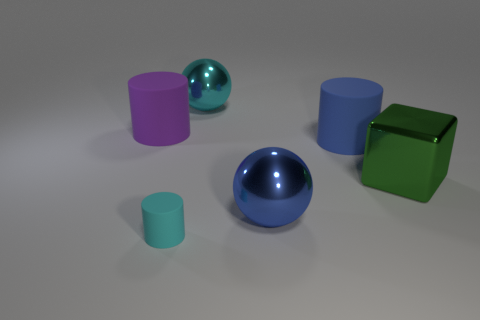Subtract all large blue cylinders. How many cylinders are left? 2 Add 3 purple shiny balls. How many objects exist? 9 Subtract all balls. How many objects are left? 4 Add 6 large cyan cylinders. How many large cyan cylinders exist? 6 Subtract all cyan spheres. How many spheres are left? 1 Subtract 0 brown blocks. How many objects are left? 6 Subtract 1 balls. How many balls are left? 1 Subtract all yellow cylinders. Subtract all purple spheres. How many cylinders are left? 3 Subtract all big metallic balls. Subtract all large purple cylinders. How many objects are left? 3 Add 3 tiny matte things. How many tiny matte things are left? 4 